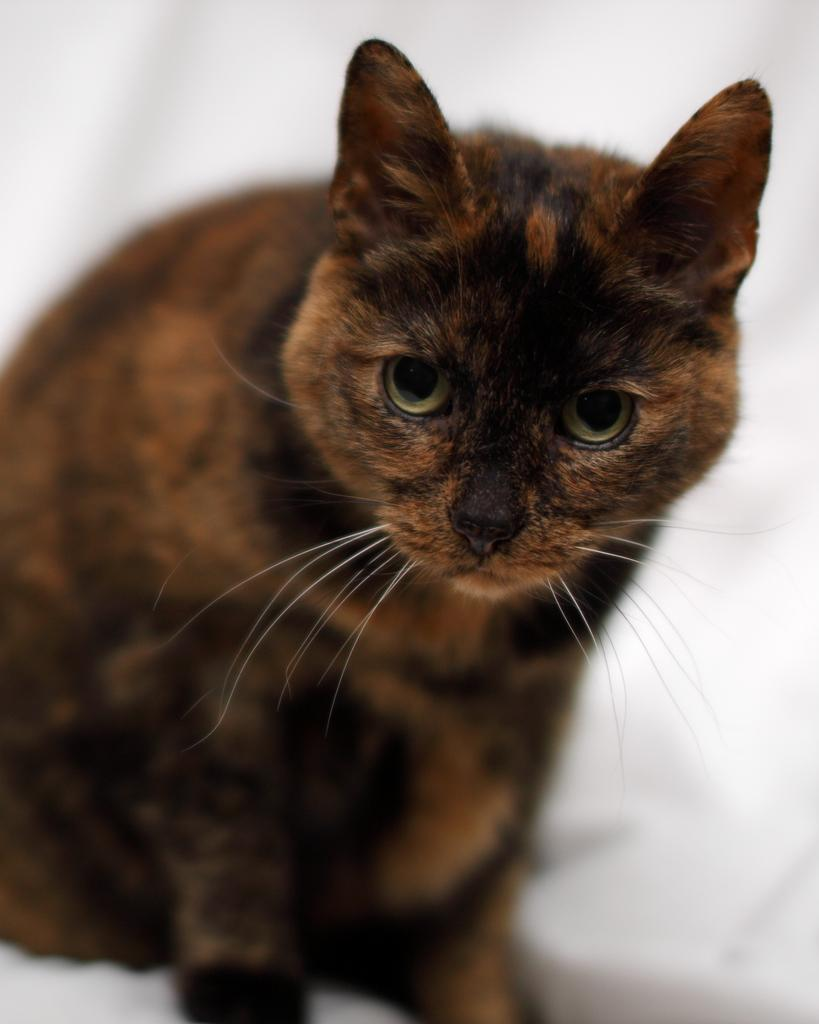What is the color of the background in the image? The background of the image is white. What is the main subject in the middle of the image? There is a cat in the middle of the image. What is the color of the cat? The cat is brown in color. Where is the cactus located in the image? There is no cactus present in the image. What type of form does the cat have in the image? The cat has a natural, feline form in the image. 